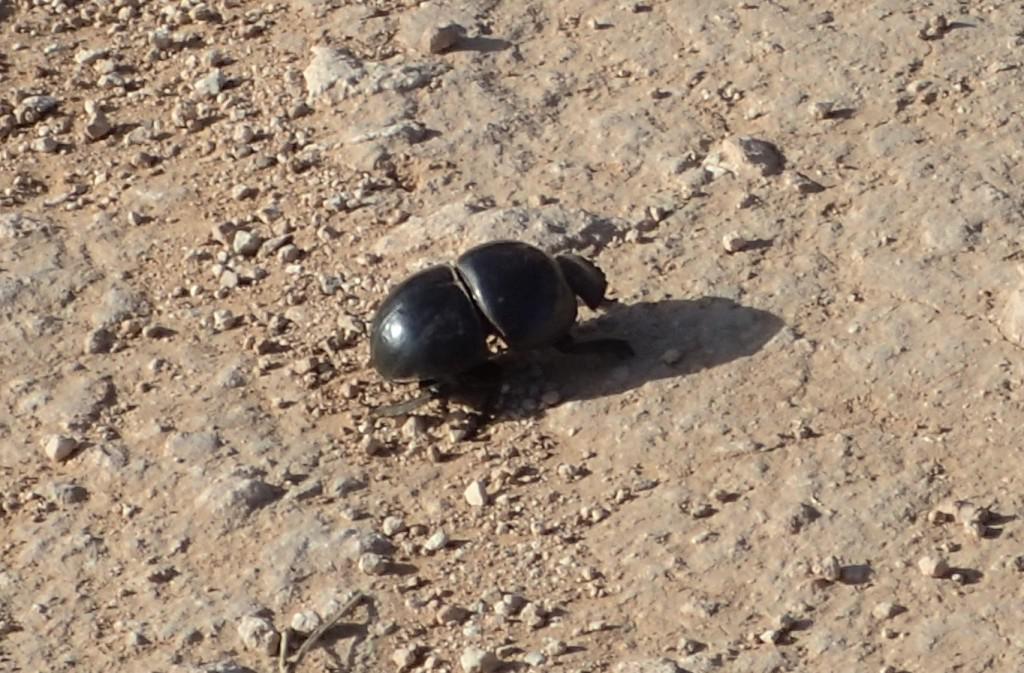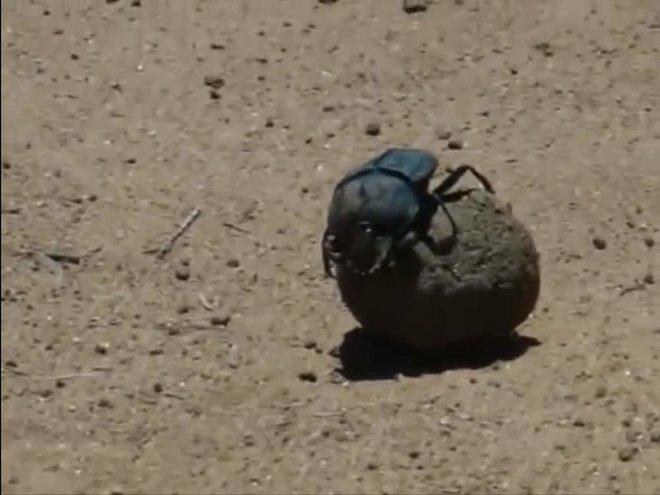The first image is the image on the left, the second image is the image on the right. Considering the images on both sides, is "The left image contains two beetles." valid? Answer yes or no. No. The first image is the image on the left, the second image is the image on the right. For the images displayed, is the sentence "There are two beetles on the clod of dirt in the image on the left." factually correct? Answer yes or no. No. 